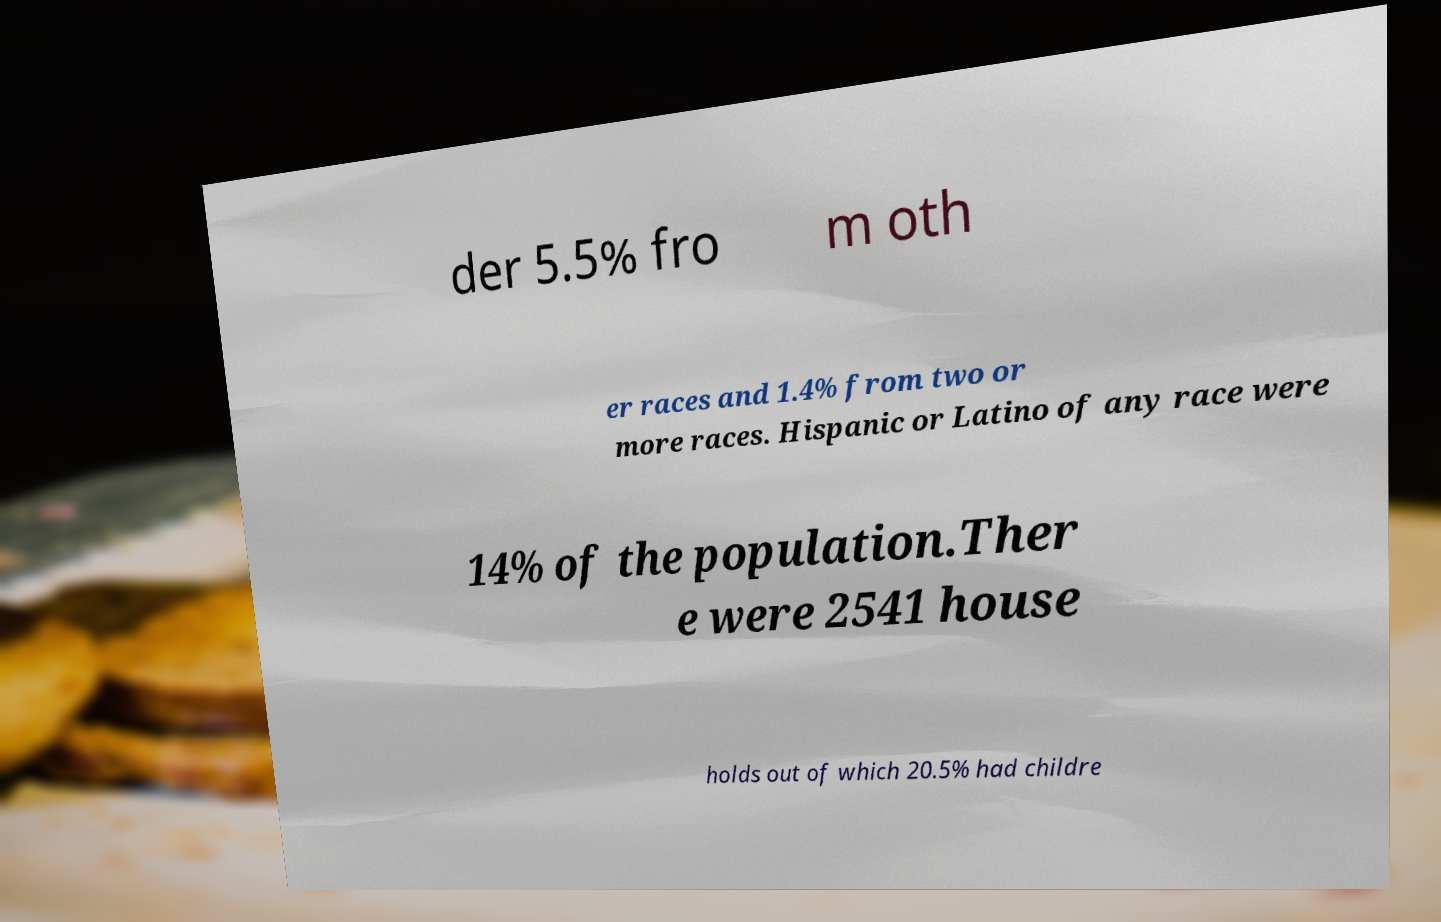Could you assist in decoding the text presented in this image and type it out clearly? der 5.5% fro m oth er races and 1.4% from two or more races. Hispanic or Latino of any race were 14% of the population.Ther e were 2541 house holds out of which 20.5% had childre 